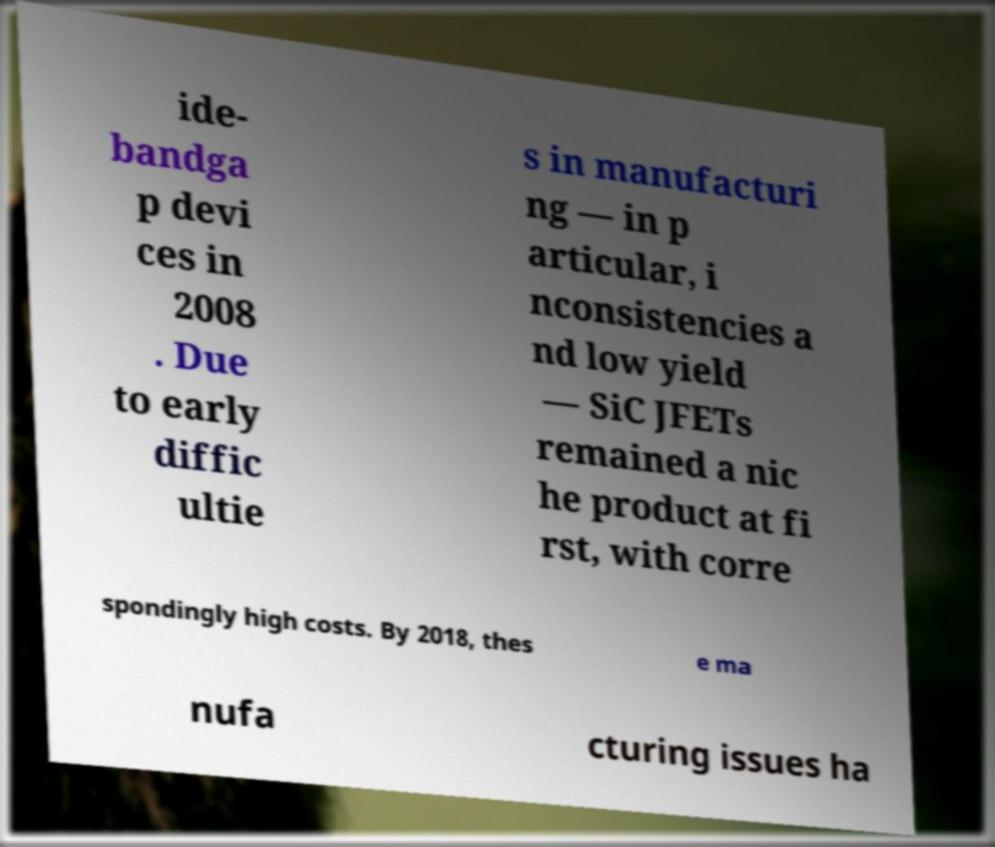For documentation purposes, I need the text within this image transcribed. Could you provide that? ide- bandga p devi ces in 2008 . Due to early diffic ultie s in manufacturi ng — in p articular, i nconsistencies a nd low yield — SiC JFETs remained a nic he product at fi rst, with corre spondingly high costs. By 2018, thes e ma nufa cturing issues ha 